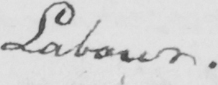Please transcribe the handwritten text in this image. Labour . 